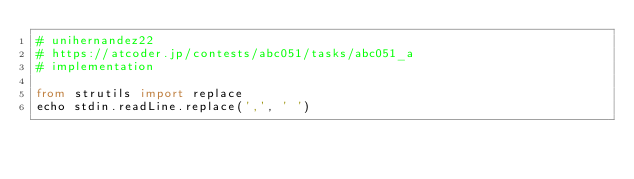Convert code to text. <code><loc_0><loc_0><loc_500><loc_500><_Nim_># unihernandez22
# https://atcoder.jp/contests/abc051/tasks/abc051_a
# implementation

from strutils import replace
echo stdin.readLine.replace(',', ' ')
</code> 